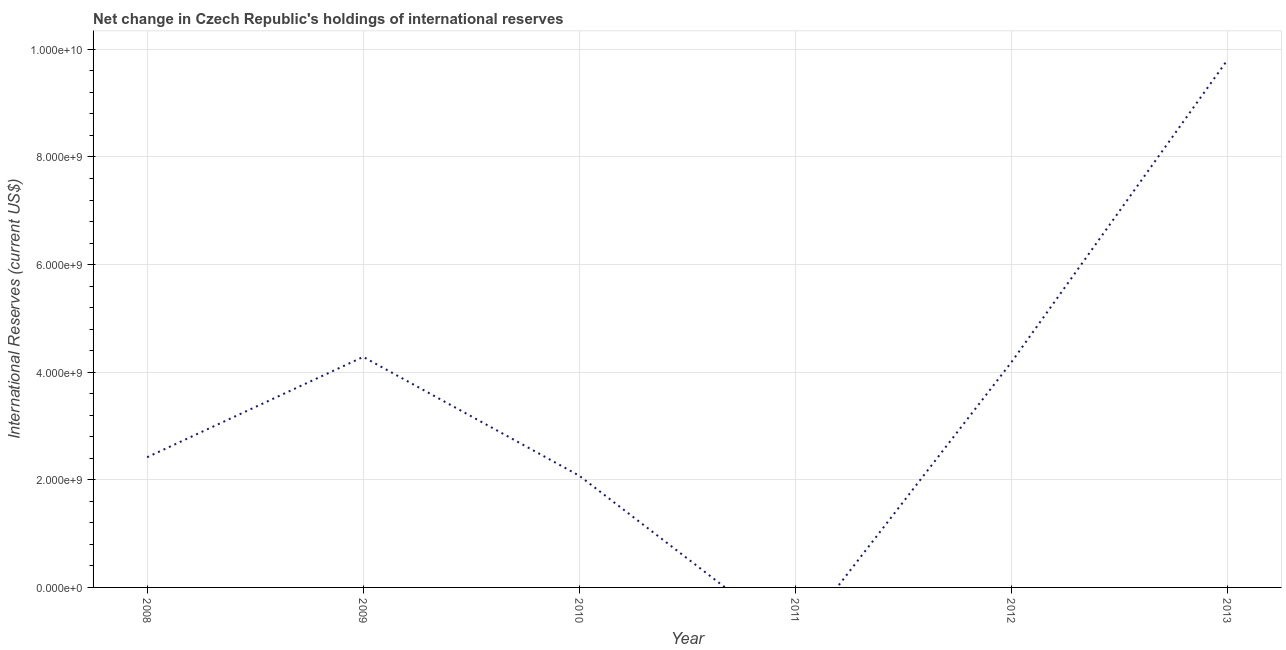What is the reserves and related items in 2013?
Provide a succinct answer. 9.80e+09. Across all years, what is the maximum reserves and related items?
Make the answer very short. 9.80e+09. In which year was the reserves and related items maximum?
Make the answer very short. 2013. What is the sum of the reserves and related items?
Offer a terse response. 2.28e+1. What is the difference between the reserves and related items in 2010 and 2013?
Offer a terse response. -7.73e+09. What is the average reserves and related items per year?
Your answer should be compact. 3.80e+09. What is the median reserves and related items?
Make the answer very short. 3.30e+09. In how many years, is the reserves and related items greater than 6400000000 US$?
Your response must be concise. 1. What is the ratio of the reserves and related items in 2009 to that in 2012?
Keep it short and to the point. 1.02. What is the difference between the highest and the second highest reserves and related items?
Keep it short and to the point. 5.52e+09. What is the difference between the highest and the lowest reserves and related items?
Your response must be concise. 9.80e+09. Does the reserves and related items monotonically increase over the years?
Keep it short and to the point. No. How many lines are there?
Your answer should be very brief. 1. How many years are there in the graph?
Provide a short and direct response. 6. Does the graph contain any zero values?
Your response must be concise. Yes. What is the title of the graph?
Ensure brevity in your answer.  Net change in Czech Republic's holdings of international reserves. What is the label or title of the Y-axis?
Your answer should be compact. International Reserves (current US$). What is the International Reserves (current US$) in 2008?
Your answer should be very brief. 2.42e+09. What is the International Reserves (current US$) in 2009?
Your response must be concise. 4.28e+09. What is the International Reserves (current US$) in 2010?
Provide a succinct answer. 2.08e+09. What is the International Reserves (current US$) in 2011?
Offer a very short reply. 0. What is the International Reserves (current US$) of 2012?
Your answer should be compact. 4.19e+09. What is the International Reserves (current US$) of 2013?
Offer a terse response. 9.80e+09. What is the difference between the International Reserves (current US$) in 2008 and 2009?
Offer a terse response. -1.86e+09. What is the difference between the International Reserves (current US$) in 2008 and 2010?
Give a very brief answer. 3.44e+08. What is the difference between the International Reserves (current US$) in 2008 and 2012?
Give a very brief answer. -1.77e+09. What is the difference between the International Reserves (current US$) in 2008 and 2013?
Offer a very short reply. -7.38e+09. What is the difference between the International Reserves (current US$) in 2009 and 2010?
Give a very brief answer. 2.21e+09. What is the difference between the International Reserves (current US$) in 2009 and 2012?
Your response must be concise. 9.81e+07. What is the difference between the International Reserves (current US$) in 2009 and 2013?
Keep it short and to the point. -5.52e+09. What is the difference between the International Reserves (current US$) in 2010 and 2012?
Provide a succinct answer. -2.11e+09. What is the difference between the International Reserves (current US$) in 2010 and 2013?
Make the answer very short. -7.73e+09. What is the difference between the International Reserves (current US$) in 2012 and 2013?
Provide a short and direct response. -5.62e+09. What is the ratio of the International Reserves (current US$) in 2008 to that in 2009?
Your answer should be compact. 0.56. What is the ratio of the International Reserves (current US$) in 2008 to that in 2010?
Your answer should be very brief. 1.17. What is the ratio of the International Reserves (current US$) in 2008 to that in 2012?
Your response must be concise. 0.58. What is the ratio of the International Reserves (current US$) in 2008 to that in 2013?
Your answer should be compact. 0.25. What is the ratio of the International Reserves (current US$) in 2009 to that in 2010?
Your answer should be compact. 2.06. What is the ratio of the International Reserves (current US$) in 2009 to that in 2012?
Ensure brevity in your answer.  1.02. What is the ratio of the International Reserves (current US$) in 2009 to that in 2013?
Your answer should be compact. 0.44. What is the ratio of the International Reserves (current US$) in 2010 to that in 2012?
Ensure brevity in your answer.  0.5. What is the ratio of the International Reserves (current US$) in 2010 to that in 2013?
Your answer should be very brief. 0.21. What is the ratio of the International Reserves (current US$) in 2012 to that in 2013?
Provide a succinct answer. 0.43. 